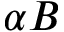Convert formula to latex. <formula><loc_0><loc_0><loc_500><loc_500>\alpha B</formula> 